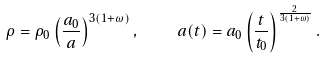Convert formula to latex. <formula><loc_0><loc_0><loc_500><loc_500>\rho = \rho _ { 0 } \left ( { \frac { a _ { 0 } } { a } } \right ) ^ { 3 ( 1 + \omega ) } , \quad a ( t ) = a _ { 0 } \left ( { \frac { t } { t _ { 0 } } } \right ) ^ { { \frac { 2 } { 3 ( 1 + \omega ) } } } .</formula> 